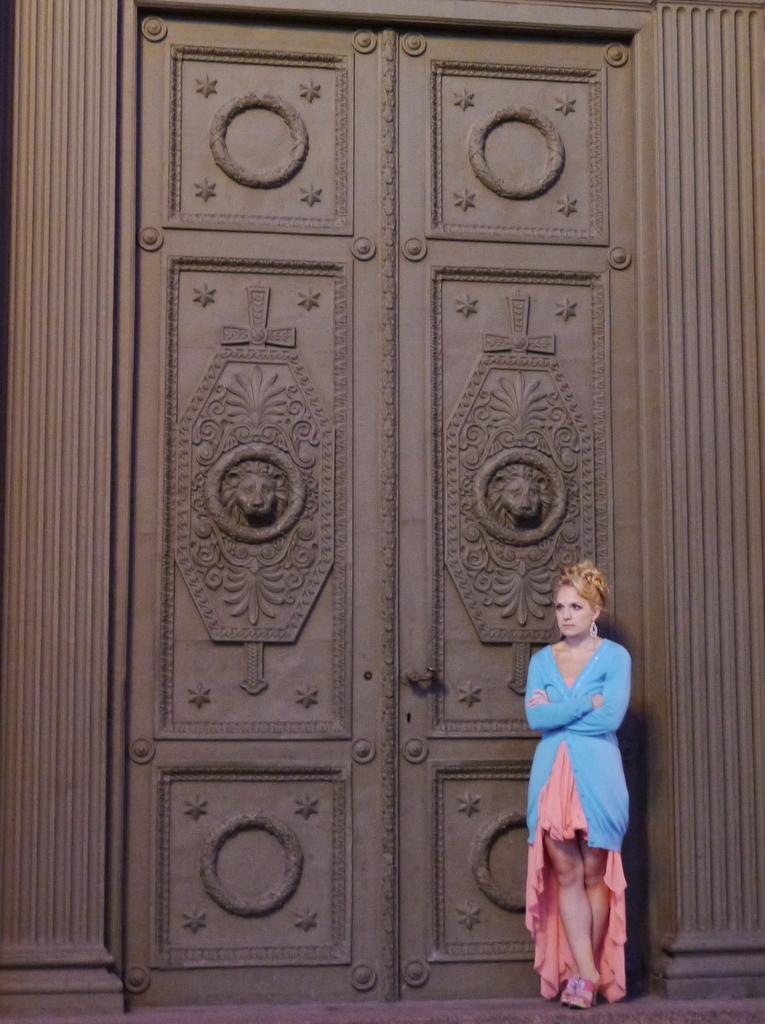Where was the image taken? The image is taken outdoors. What can be seen in the background of the image? There is a wall with a door in the background. What is special about the door? The door has carvings. Who is present in the image? A woman is standing on the right side of the image. What is the woman standing on? The woman is standing on the floor. What type of desk is the doctor using to examine the parent in the image? There is no desk, doctor, or parent present in the image. 